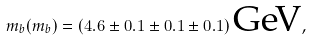Convert formula to latex. <formula><loc_0><loc_0><loc_500><loc_500>m _ { b } ( m _ { b } ) = ( 4 . 6 \pm 0 . 1 \pm 0 . 1 \pm 0 . 1 ) \, \text {GeV} ,</formula> 